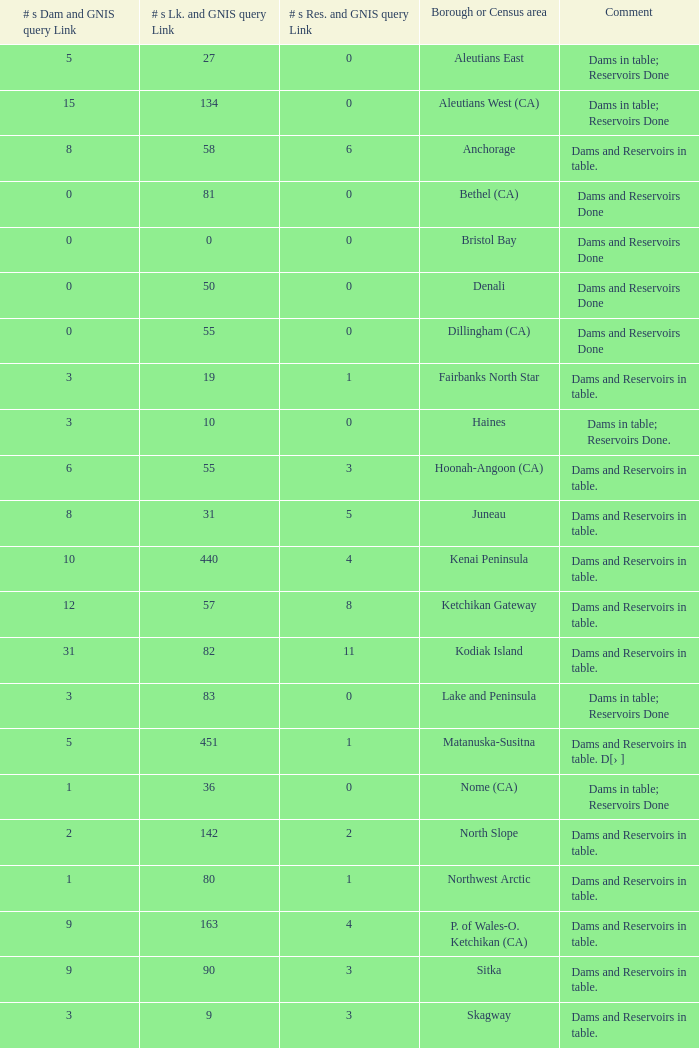Name the minimum number of reservoir for gnis query link where numbers lake gnis query link being 60 5.0. 